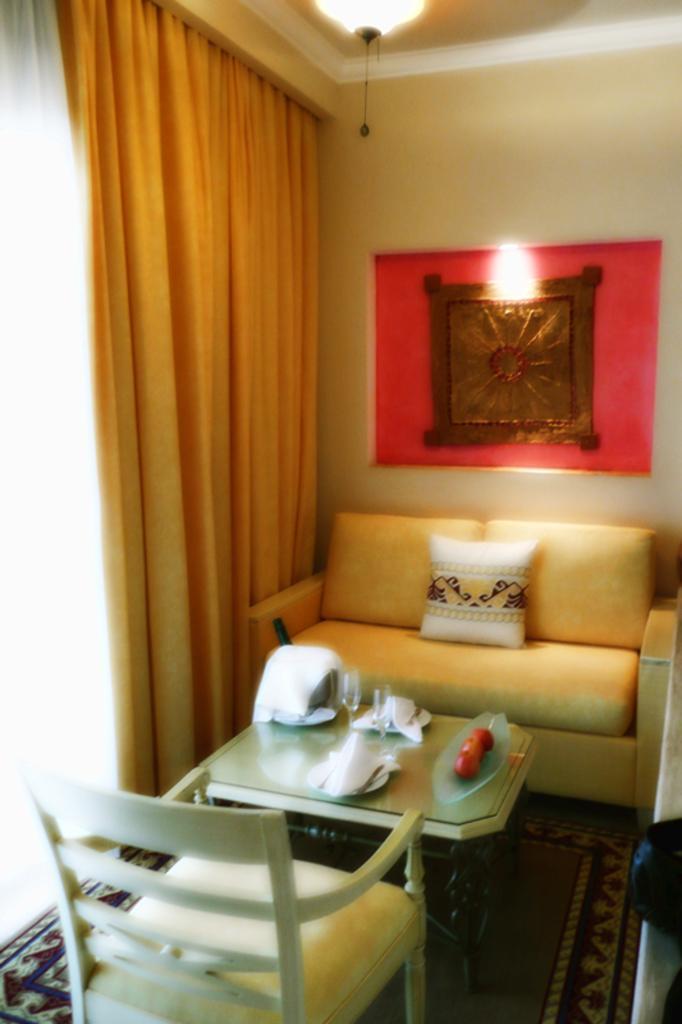Describe this image in one or two sentences. This picture is taken inside a room. There is a couch, a table and chair in the room. On the table there are glasses, plates and apples. On the couch there is a cushion. On the floor there is a carpet. On the wall there is a frame. To the left corner of the image there is curtain. To the top there is chandelier. 